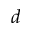<formula> <loc_0><loc_0><loc_500><loc_500>d</formula> 